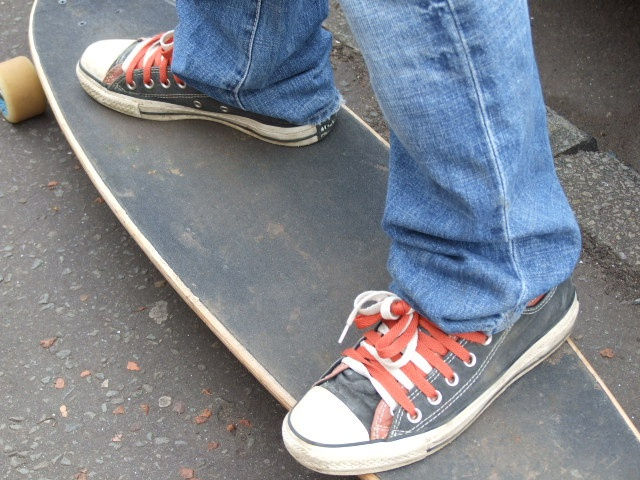Describe the objects in this image and their specific colors. I can see people in darkgray, gray, and white tones and skateboard in darkgray and gray tones in this image. 